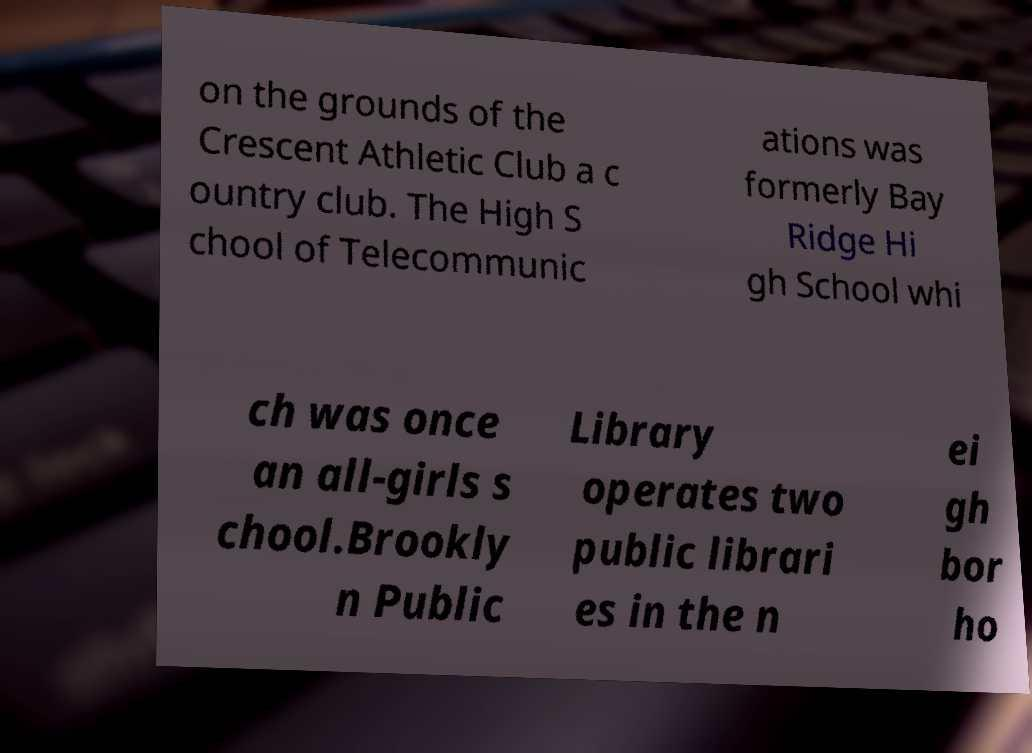Can you read and provide the text displayed in the image?This photo seems to have some interesting text. Can you extract and type it out for me? on the grounds of the Crescent Athletic Club a c ountry club. The High S chool of Telecommunic ations was formerly Bay Ridge Hi gh School whi ch was once an all-girls s chool.Brookly n Public Library operates two public librari es in the n ei gh bor ho 